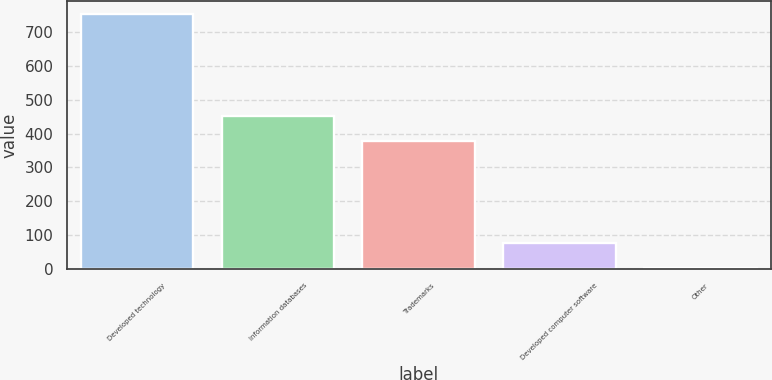Convert chart to OTSL. <chart><loc_0><loc_0><loc_500><loc_500><bar_chart><fcel>Developed technology<fcel>Information databases<fcel>Trademarks<fcel>Developed computer software<fcel>Other<nl><fcel>754.2<fcel>452.66<fcel>377.5<fcel>77.76<fcel>2.6<nl></chart> 